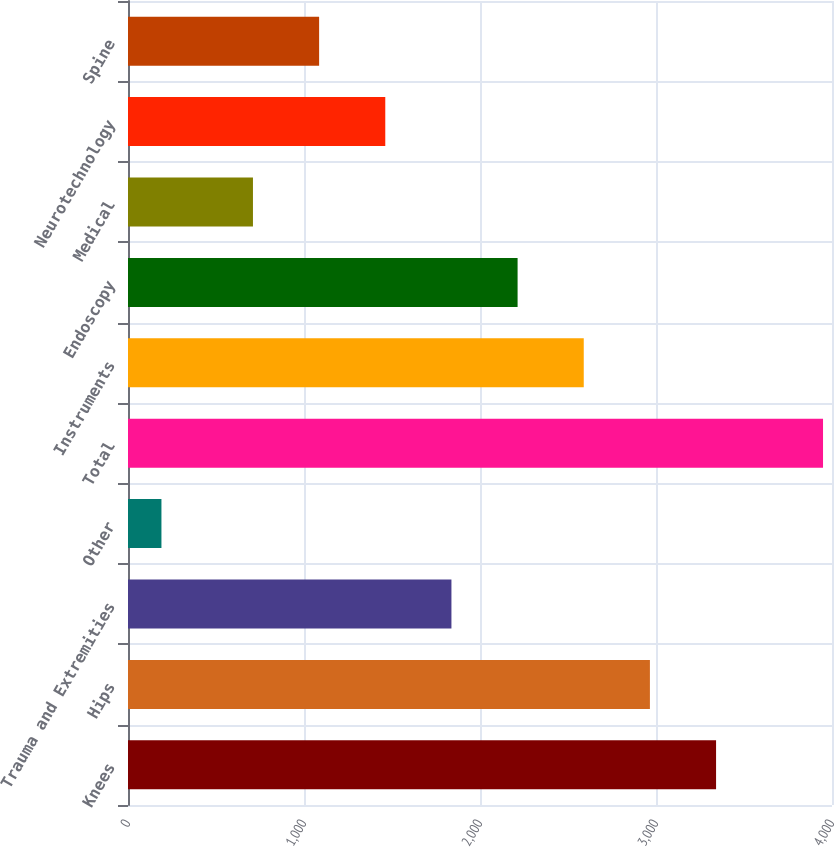<chart> <loc_0><loc_0><loc_500><loc_500><bar_chart><fcel>Knees<fcel>Hips<fcel>Trauma and Extremities<fcel>Other<fcel>Total<fcel>Instruments<fcel>Endoscopy<fcel>Medical<fcel>Neurotechnology<fcel>Spine<nl><fcel>3341.3<fcel>2965.4<fcel>1837.7<fcel>190<fcel>3949<fcel>2589.5<fcel>2213.6<fcel>710<fcel>1461.8<fcel>1085.9<nl></chart> 